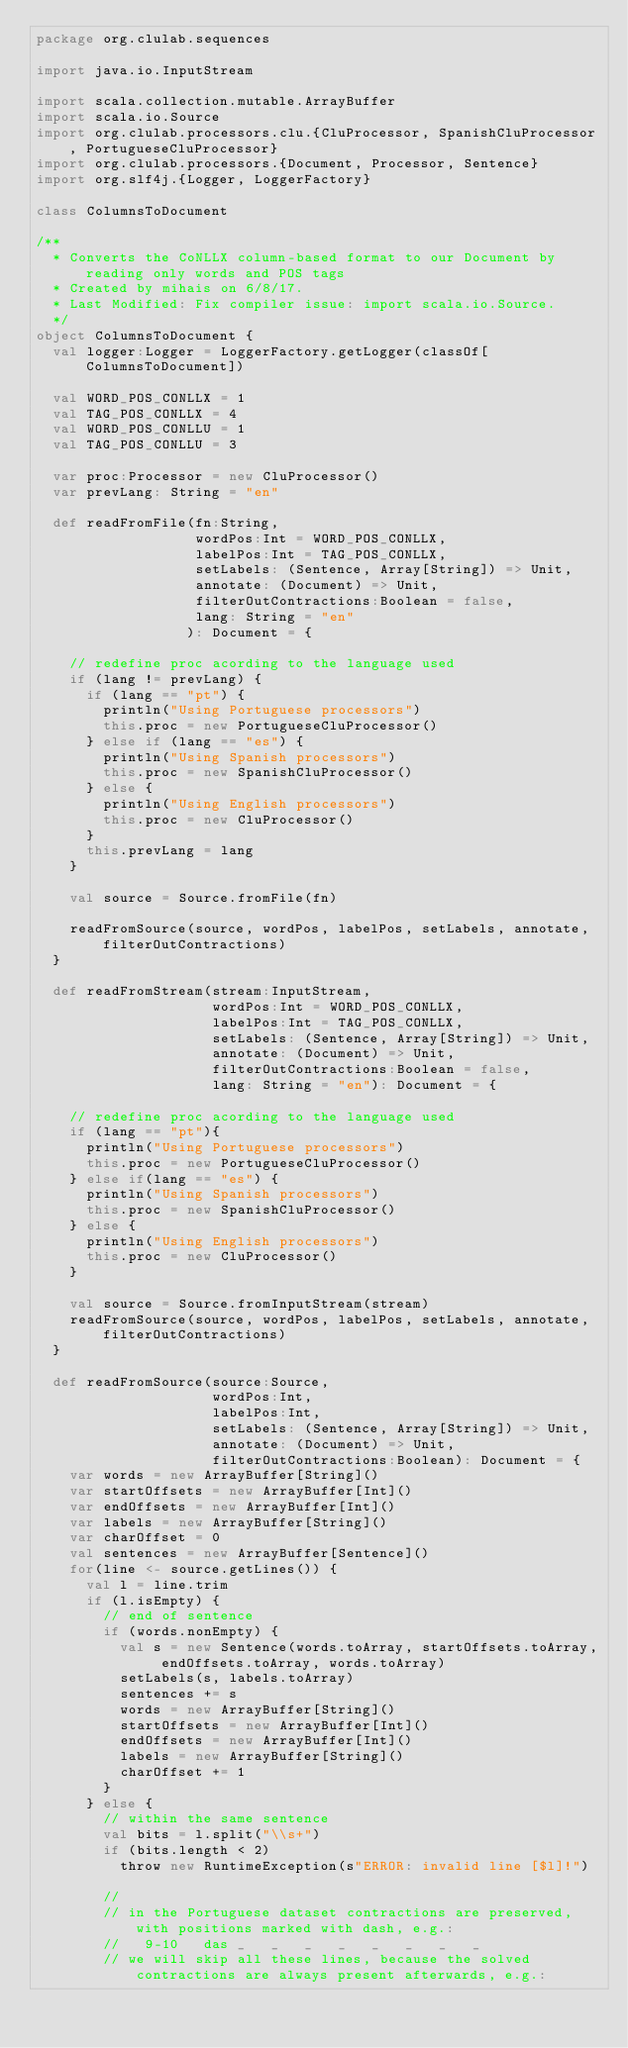Convert code to text. <code><loc_0><loc_0><loc_500><loc_500><_Scala_>package org.clulab.sequences

import java.io.InputStream

import scala.collection.mutable.ArrayBuffer
import scala.io.Source
import org.clulab.processors.clu.{CluProcessor, SpanishCluProcessor, PortugueseCluProcessor}
import org.clulab.processors.{Document, Processor, Sentence}
import org.slf4j.{Logger, LoggerFactory}

class ColumnsToDocument

/**
  * Converts the CoNLLX column-based format to our Document by reading only words and POS tags
  * Created by mihais on 6/8/17.
  * Last Modified: Fix compiler issue: import scala.io.Source.
  */
object ColumnsToDocument {
  val logger:Logger = LoggerFactory.getLogger(classOf[ColumnsToDocument])

  val WORD_POS_CONLLX = 1
  val TAG_POS_CONLLX = 4
  val WORD_POS_CONLLU = 1
  val TAG_POS_CONLLU = 3

  var proc:Processor = new CluProcessor()
  var prevLang: String = "en"

  def readFromFile(fn:String,
                   wordPos:Int = WORD_POS_CONLLX,
                   labelPos:Int = TAG_POS_CONLLX,
                   setLabels: (Sentence, Array[String]) => Unit,
                   annotate: (Document) => Unit,
                   filterOutContractions:Boolean = false,
                   lang: String = "en"
                  ): Document = {

    // redefine proc acording to the language used
    if (lang != prevLang) {
      if (lang == "pt") {
        println("Using Portuguese processors")
        this.proc = new PortugueseCluProcessor()
      } else if (lang == "es") {
        println("Using Spanish processors")
        this.proc = new SpanishCluProcessor()
      } else {
        println("Using English processors")
        this.proc = new CluProcessor()
      }
      this.prevLang = lang
    }

    val source = Source.fromFile(fn)

    readFromSource(source, wordPos, labelPos, setLabels, annotate, filterOutContractions)
  }

  def readFromStream(stream:InputStream,
                     wordPos:Int = WORD_POS_CONLLX,
                     labelPos:Int = TAG_POS_CONLLX,
                     setLabels: (Sentence, Array[String]) => Unit,
                     annotate: (Document) => Unit,
                     filterOutContractions:Boolean = false,
                     lang: String = "en"): Document = {

    // redefine proc acording to the language used
    if (lang == "pt"){
      println("Using Portuguese processors")
      this.proc = new PortugueseCluProcessor()
    } else if(lang == "es") {
      println("Using Spanish processors")
      this.proc = new SpanishCluProcessor()
    } else {
      println("Using English processors")
      this.proc = new CluProcessor()
    }

    val source = Source.fromInputStream(stream)
    readFromSource(source, wordPos, labelPos, setLabels, annotate, filterOutContractions)
  }

  def readFromSource(source:Source,
                     wordPos:Int,
                     labelPos:Int,
                     setLabels: (Sentence, Array[String]) => Unit,
                     annotate: (Document) => Unit,
                     filterOutContractions:Boolean): Document = {
    var words = new ArrayBuffer[String]()
    var startOffsets = new ArrayBuffer[Int]()
    var endOffsets = new ArrayBuffer[Int]()
    var labels = new ArrayBuffer[String]()
    var charOffset = 0
    val sentences = new ArrayBuffer[Sentence]()
    for(line <- source.getLines()) {
      val l = line.trim
      if (l.isEmpty) {
        // end of sentence
        if (words.nonEmpty) {
          val s = new Sentence(words.toArray, startOffsets.toArray, endOffsets.toArray, words.toArray)
          setLabels(s, labels.toArray)
          sentences += s
          words = new ArrayBuffer[String]()
          startOffsets = new ArrayBuffer[Int]()
          endOffsets = new ArrayBuffer[Int]()
          labels = new ArrayBuffer[String]()
          charOffset += 1
        }
      } else {
        // within the same sentence
        val bits = l.split("\\s+")
        if (bits.length < 2)
          throw new RuntimeException(s"ERROR: invalid line [$l]!")

        //
        // in the Portuguese dataset contractions are preserved, with positions marked with dash, e.g.:
        //   9-10	das	_	_	_	_	_	_	_	_
        // we will skip all these lines, because the solved contractions are always present afterwards, e.g.:</code> 